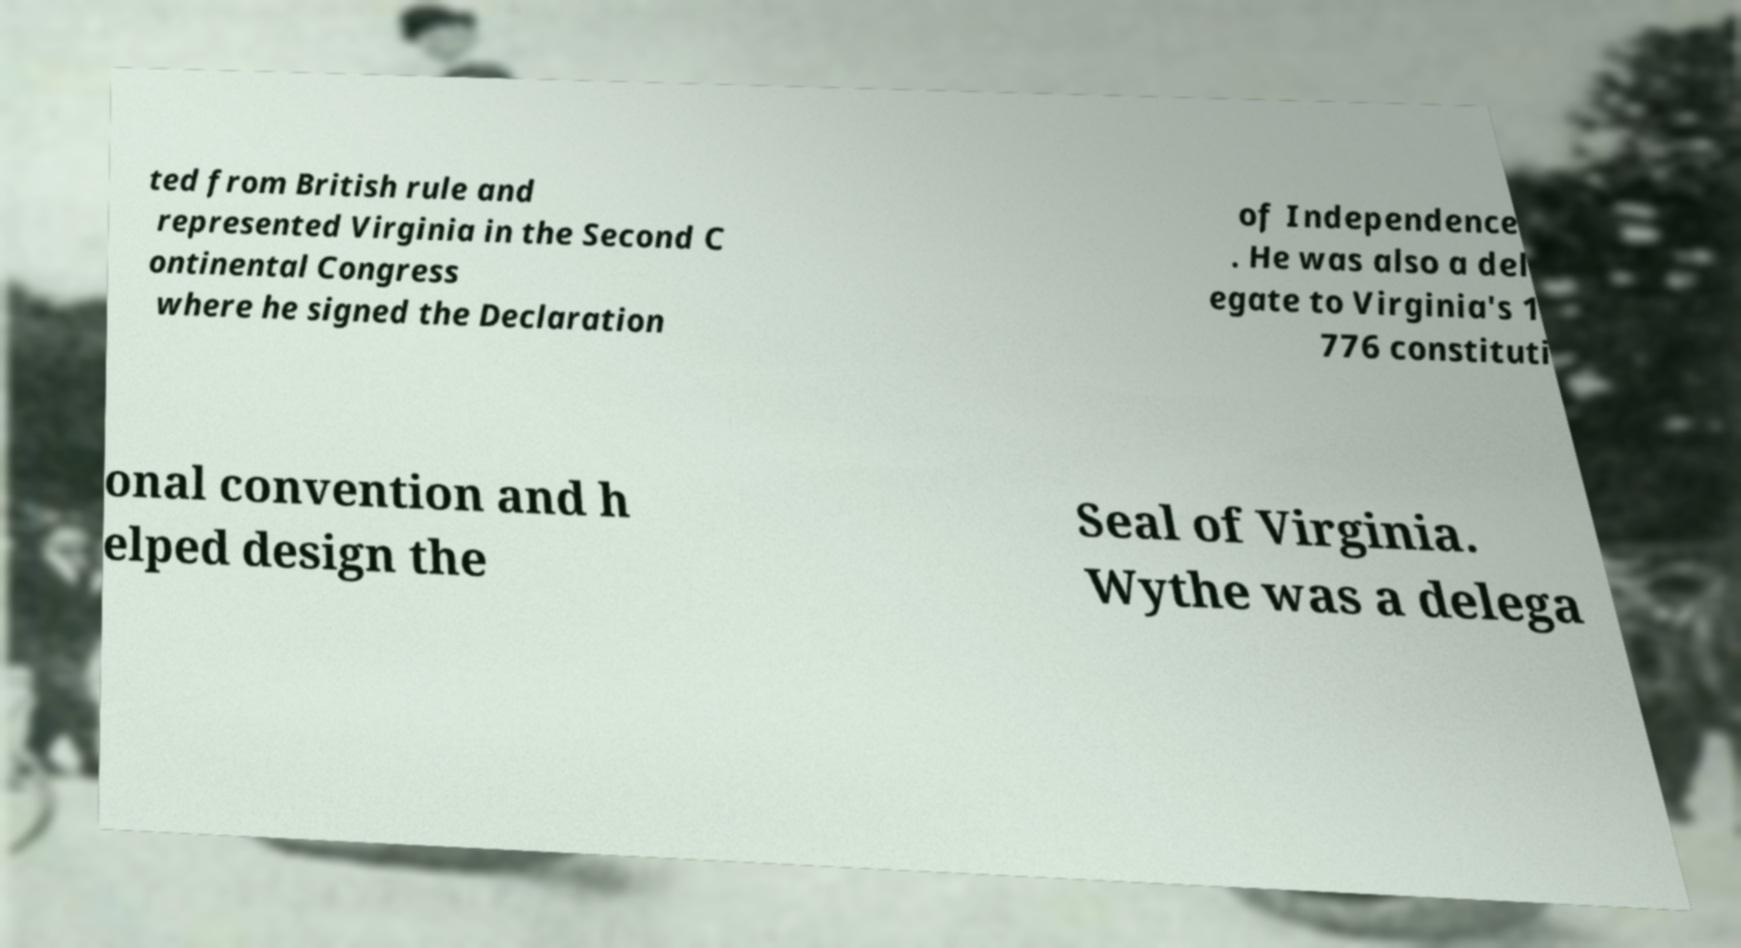Can you accurately transcribe the text from the provided image for me? ted from British rule and represented Virginia in the Second C ontinental Congress where he signed the Declaration of Independence . He was also a del egate to Virginia's 1 776 constituti onal convention and h elped design the Seal of Virginia. Wythe was a delega 